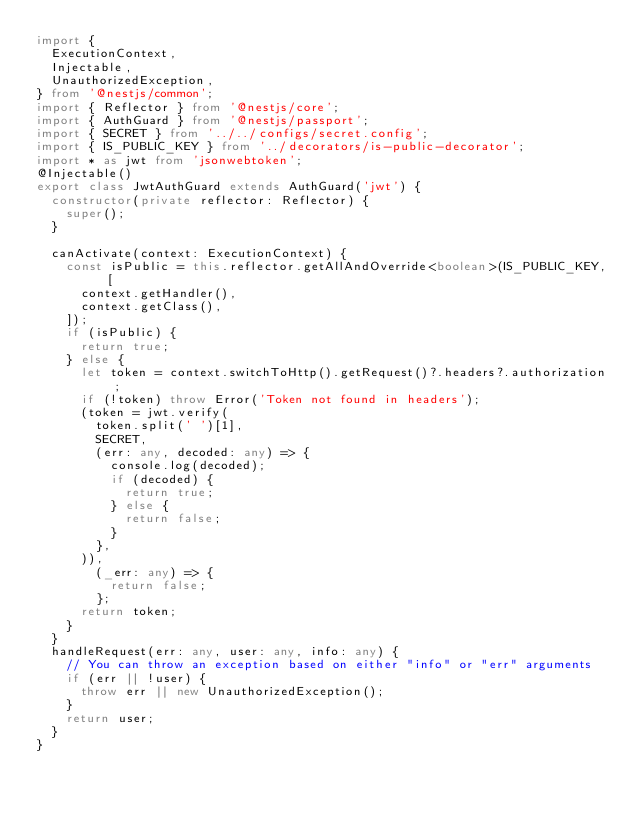Convert code to text. <code><loc_0><loc_0><loc_500><loc_500><_TypeScript_>import {
  ExecutionContext,
  Injectable,
  UnauthorizedException,
} from '@nestjs/common';
import { Reflector } from '@nestjs/core';
import { AuthGuard } from '@nestjs/passport';
import { SECRET } from '../../configs/secret.config';
import { IS_PUBLIC_KEY } from '../decorators/is-public-decorator';
import * as jwt from 'jsonwebtoken';
@Injectable()
export class JwtAuthGuard extends AuthGuard('jwt') {
  constructor(private reflector: Reflector) {
    super();
  }

  canActivate(context: ExecutionContext) {
    const isPublic = this.reflector.getAllAndOverride<boolean>(IS_PUBLIC_KEY, [
      context.getHandler(),
      context.getClass(),
    ]);
    if (isPublic) {
      return true;
    } else {
      let token = context.switchToHttp().getRequest()?.headers?.authorization;
      if (!token) throw Error('Token not found in headers');
      (token = jwt.verify(
        token.split(' ')[1],
        SECRET,
        (err: any, decoded: any) => {
          console.log(decoded);
          if (decoded) {
            return true;
          } else {
            return false;
          }
        },
      )),
        (_err: any) => {
          return false;
        };
      return token;
    }
  }
  handleRequest(err: any, user: any, info: any) {
    // You can throw an exception based on either "info" or "err" arguments
    if (err || !user) {
      throw err || new UnauthorizedException();
    }
    return user;
  }
}
</code> 